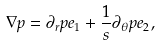<formula> <loc_0><loc_0><loc_500><loc_500>\nabla p = \partial _ { r } p e _ { 1 } + \frac { 1 } { s } \partial _ { \theta } p e _ { 2 } ,</formula> 